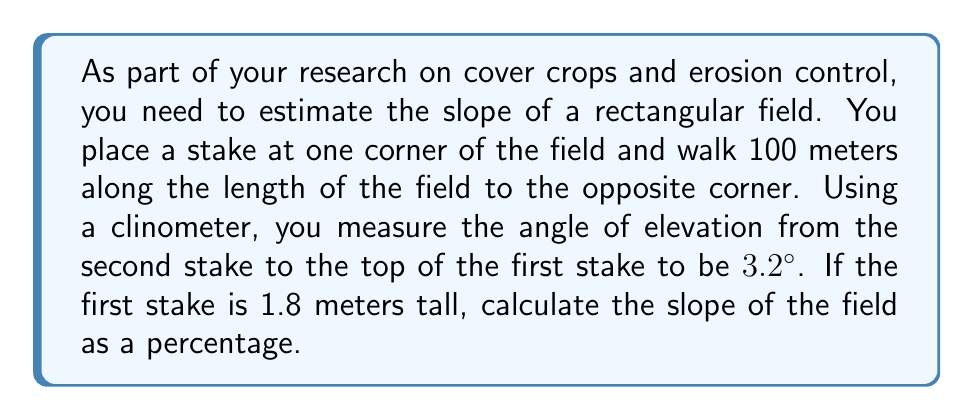Teach me how to tackle this problem. Let's approach this step-by-step:

1) First, let's visualize the problem:

[asy]
import geometry;

unitsize(1cm);

pair A = (0,0);
pair B = (10,0);
pair C = (0,0.576);
pair D = (10,0.576);

draw(A--B--D--C--cycle);
draw(A--C,dashed);

label("100 m",B,(0,-1));
label("1.8 m",C,(0,1));
label("3.2°",(0,0),SW);

[/asy]

2) We can use the tangent function to find the height difference:

   $\tan(3.2°) = \frac{\text{height difference}}{\text{distance}}$

3) Rearrange the equation:

   $\text{height difference} = 100 \cdot \tan(3.2°)$

4) Calculate:

   $\text{height difference} = 100 \cdot \tan(3.2°) = 100 \cdot 0.05592 = 5.592$ meters

5) The slope as a percentage is calculated as:

   $\text{Slope (%)} = \frac{\text{rise}}{\text{run}} \cdot 100\%$

6) In this case:
   
   $\text{Slope (%)} = \frac{5.592}{100} \cdot 100\% = 5.592\%$

Therefore, the slope of the field is approximately 5.592%.
Answer: 5.592% 